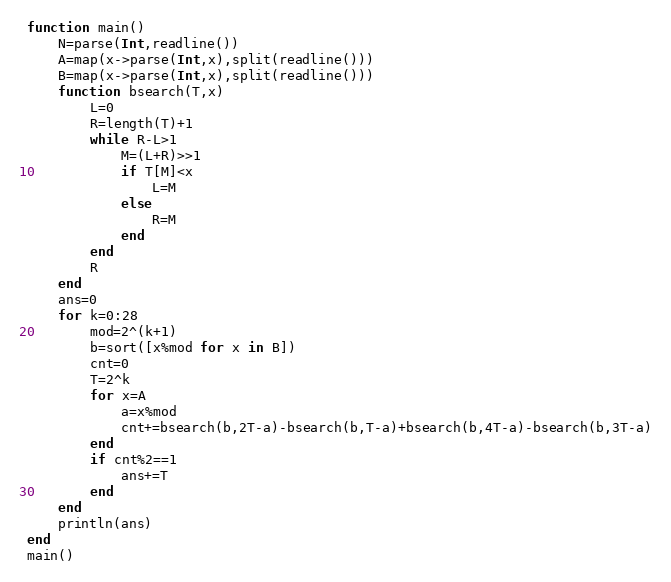Convert code to text. <code><loc_0><loc_0><loc_500><loc_500><_Julia_>function main()
	N=parse(Int,readline())
	A=map(x->parse(Int,x),split(readline()))
	B=map(x->parse(Int,x),split(readline()))
	function bsearch(T,x)
		L=0
		R=length(T)+1
		while R-L>1
			M=(L+R)>>1
			if T[M]<x
				L=M
			else
				R=M
			end
		end
		R
	end
	ans=0
	for k=0:28
		mod=2^(k+1)
		b=sort([x%mod for x in B])
		cnt=0
		T=2^k
		for x=A
			a=x%mod
			cnt+=bsearch(b,2T-a)-bsearch(b,T-a)+bsearch(b,4T-a)-bsearch(b,3T-a)
		end
		if cnt%2==1
			ans+=T
		end
	end
	println(ans)
end
main()</code> 